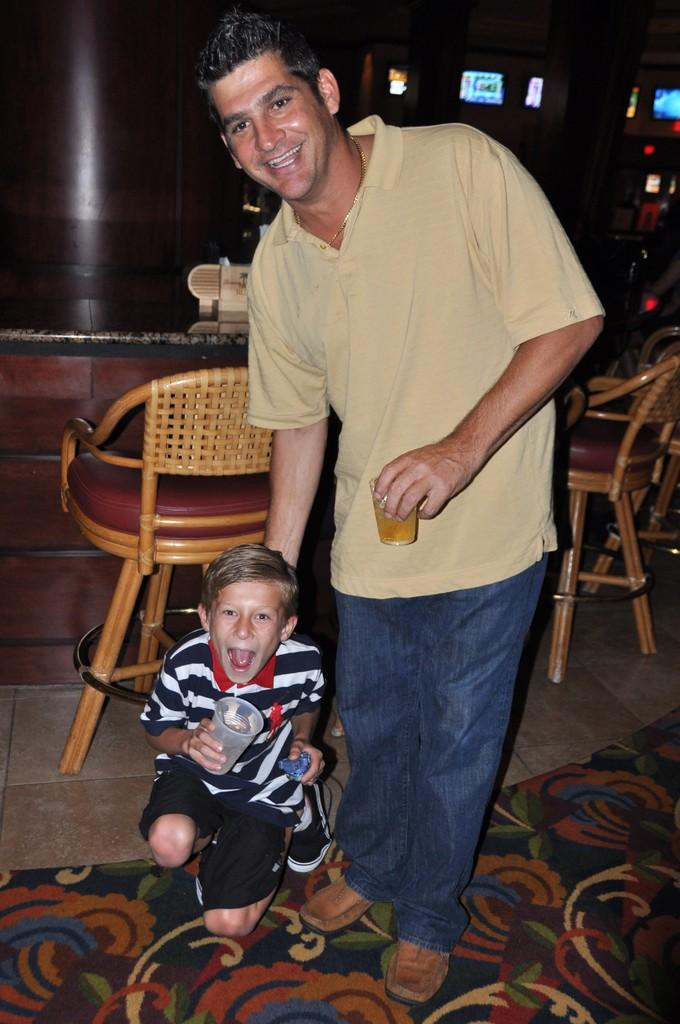How many people are in the image? There are two persons in the image. What are the persons doing in the image? The persons are standing and smiling. What can be seen in the background of the image? There is a chair, tables, and a small screen in the background of the image. What is the tendency of the farmer in the image? There is no farmer present in the image. What type of machine is visible in the image? There is no machine visible in the image. 